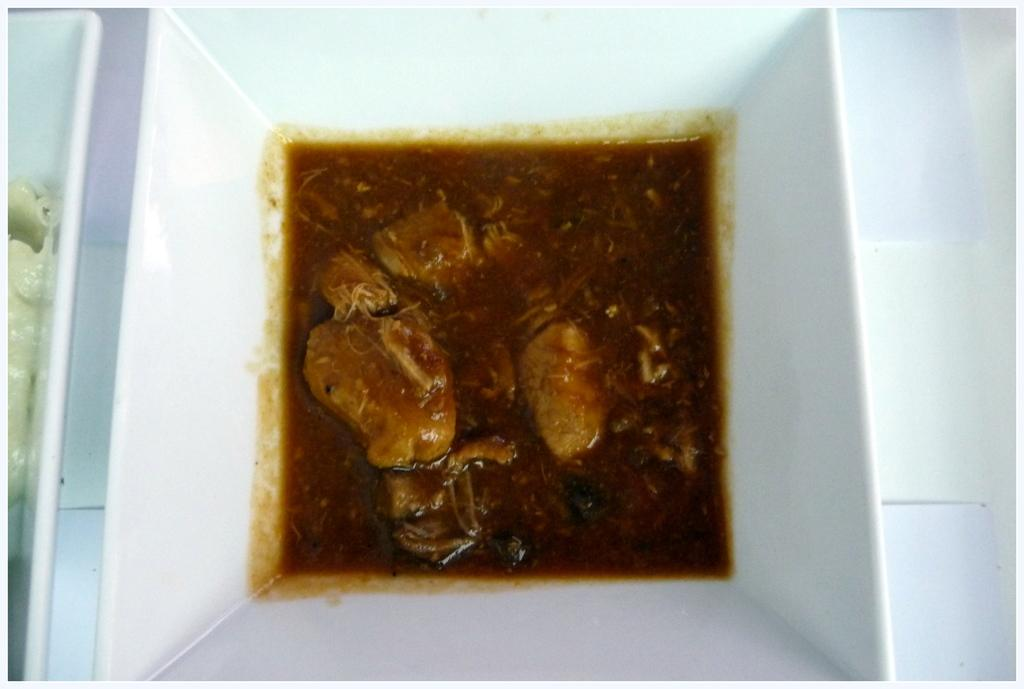What type of dish is shown in the image? There is a chicken curry in the image. What color is the bowl that contains the chicken curry? The bowl is white in color. What type of hat is visible in the image? There is no hat present in the image. What unit of measurement is used to determine the quantity of chicken curry in the image? The quantity of chicken curry is not specified in the image, so it is not possible to determine the unit of measurement. 